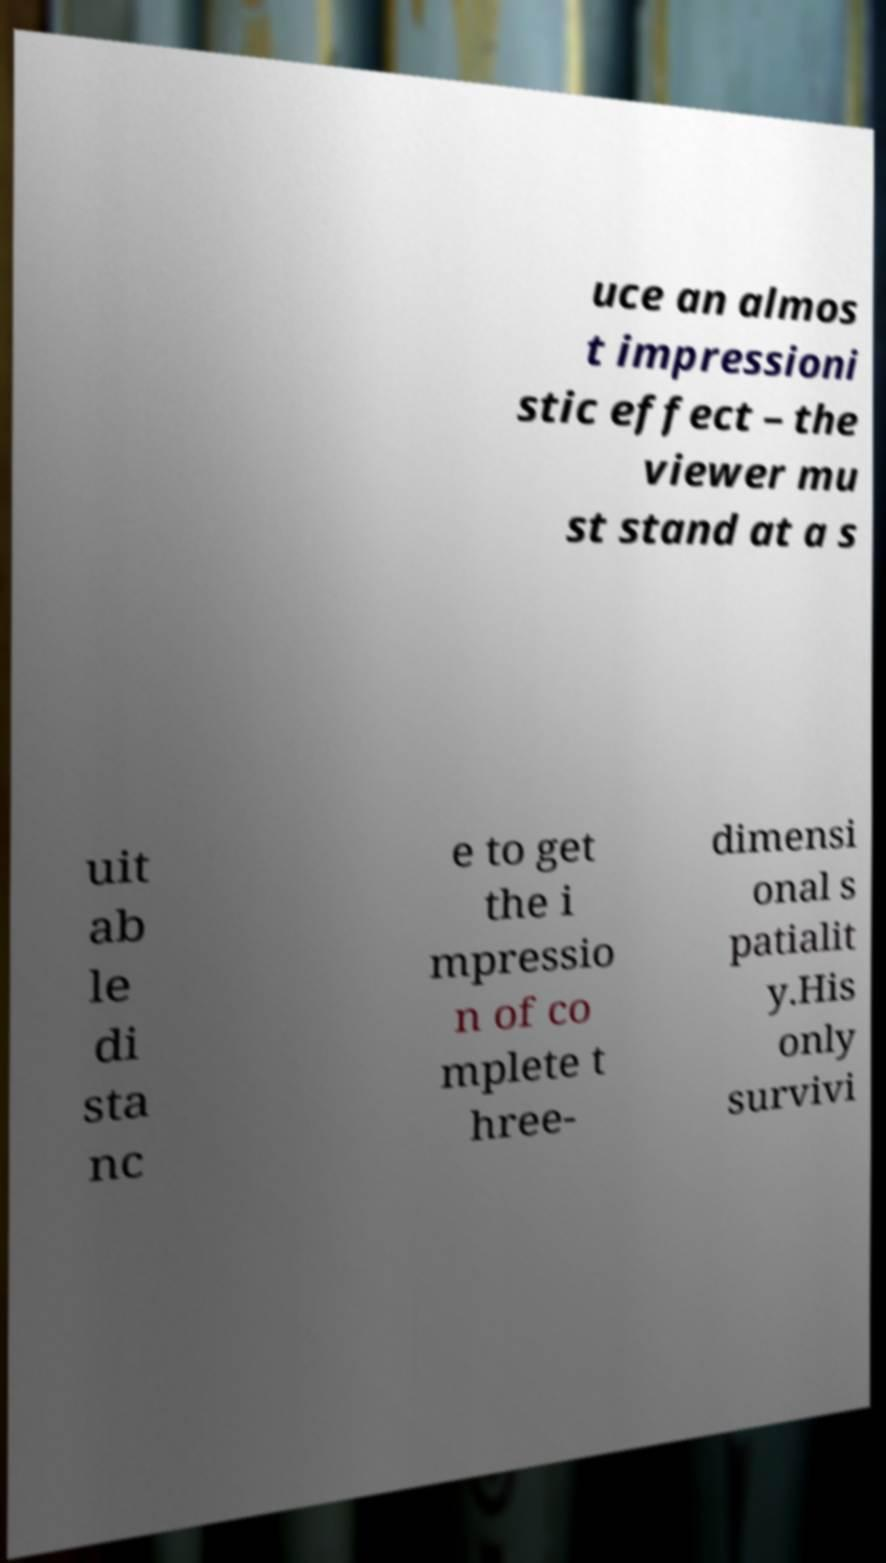Can you accurately transcribe the text from the provided image for me? uce an almos t impressioni stic effect – the viewer mu st stand at a s uit ab le di sta nc e to get the i mpressio n of co mplete t hree- dimensi onal s patialit y.His only survivi 